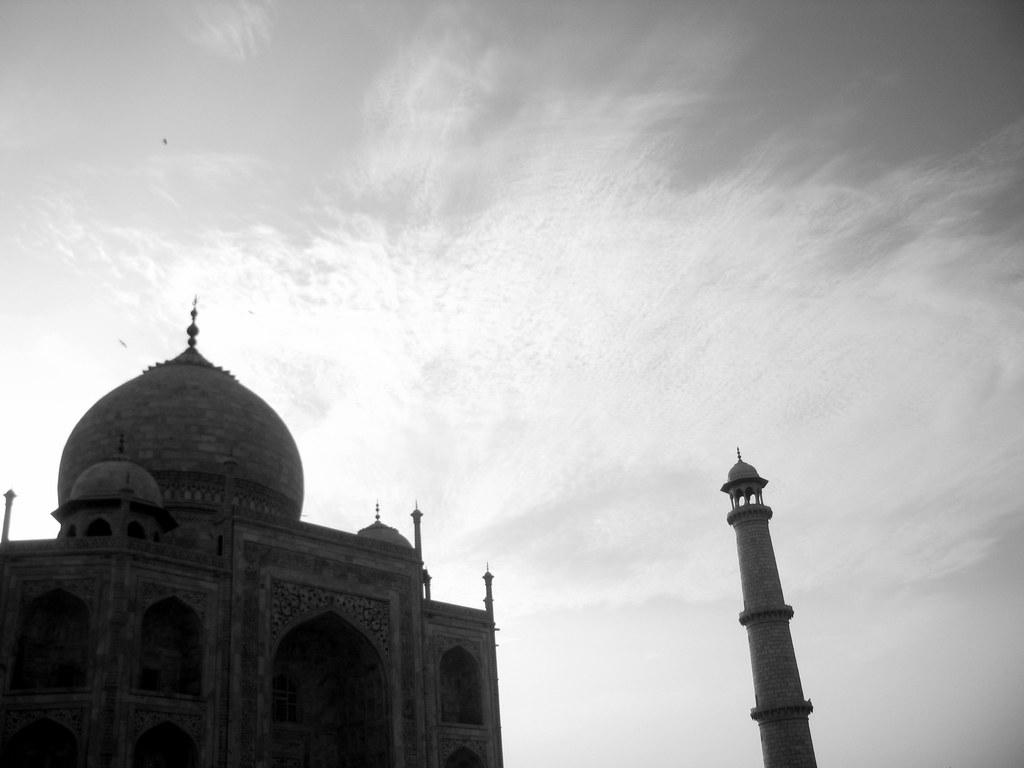What can be seen in the sky in the image? The sky is visible in the image, and clouds are present. What type of structure is in the image? There is a pillar and a monument in the image. What type of bushes can be seen growing under the monument in the image? There is no mention of bushes in the image; it only features a sky with clouds, a pillar, and a monument. What color is the dress worn by the monument in the image? The monument is an inanimate object and does not wear clothing, so there is no dress present in the image. 